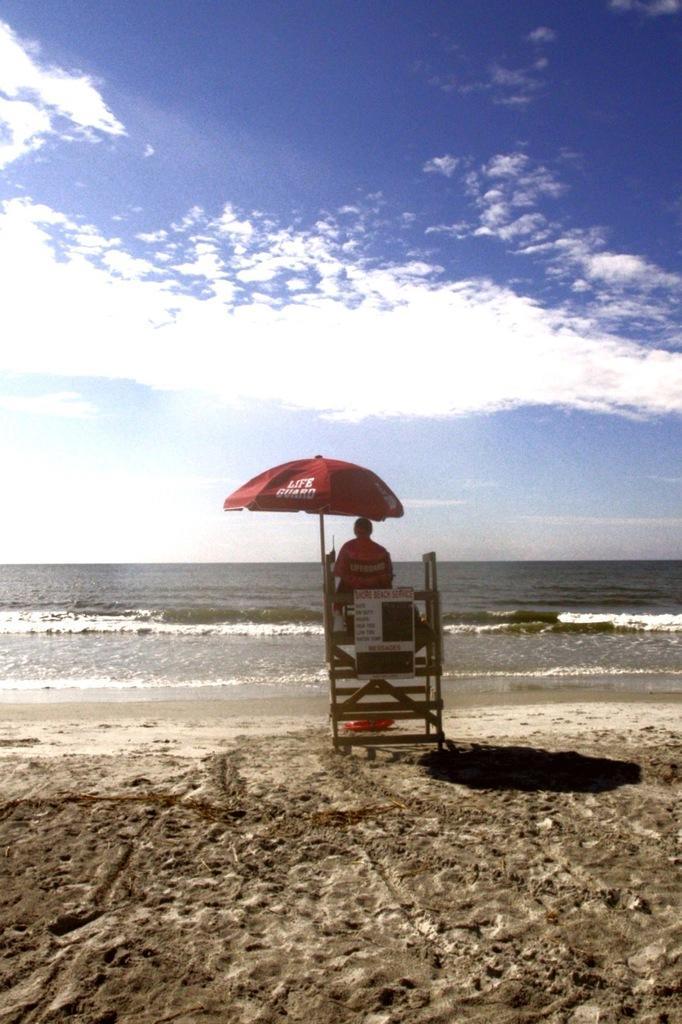In one or two sentences, can you explain what this image depicts? In this image there is a person sitting on a wooden structure under a tent, in front of the person there is sea, at the top of the image there are clouds in the sky. 